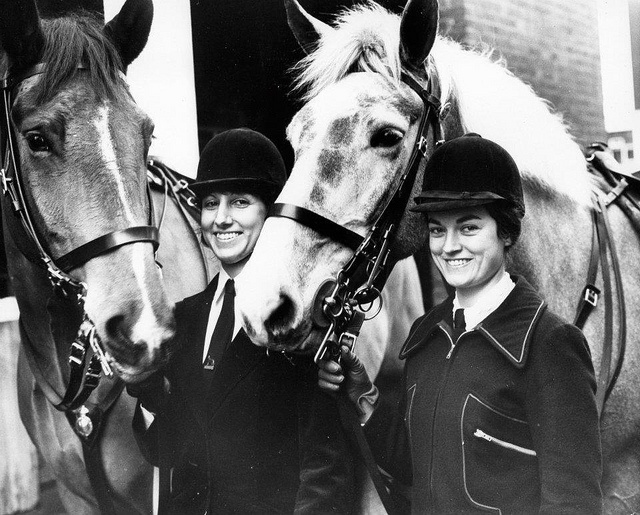Describe the objects in this image and their specific colors. I can see horse in black, white, darkgray, and gray tones, people in black, gray, lightgray, and darkgray tones, horse in black, gray, darkgray, and lightgray tones, people in black, lightgray, gray, and darkgray tones, and tie in black, gray, darkgray, and lightgray tones in this image. 